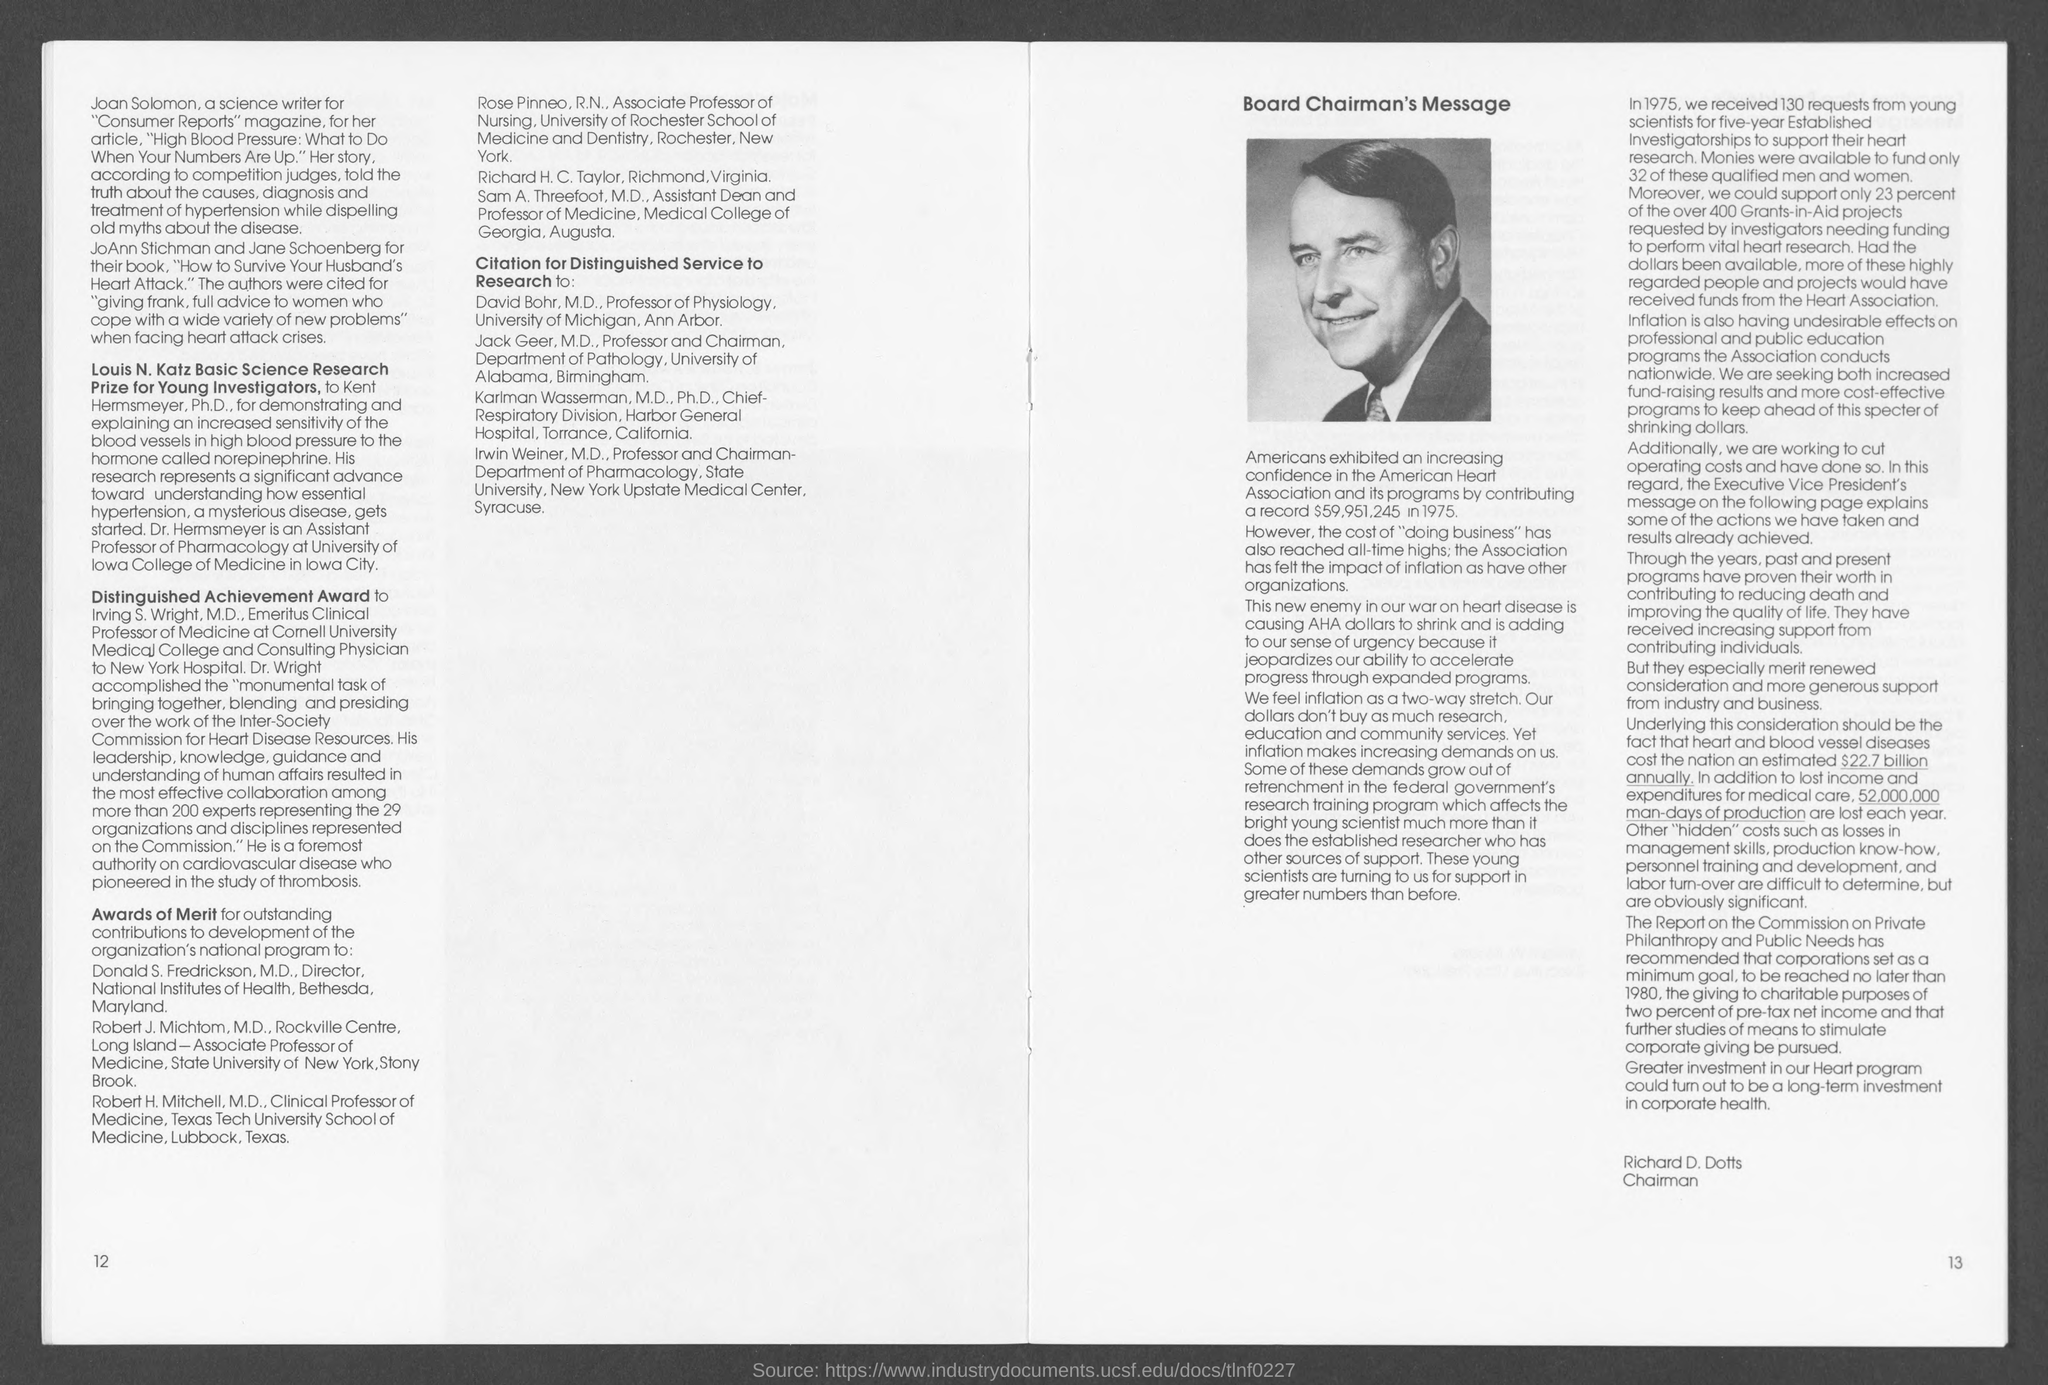What is the position of richard d. dotts ?
Provide a short and direct response. Chairman. What is the number at bottom left page ?
Make the answer very short. 12. What is the number at bottom right page?
Provide a succinct answer. 13. 